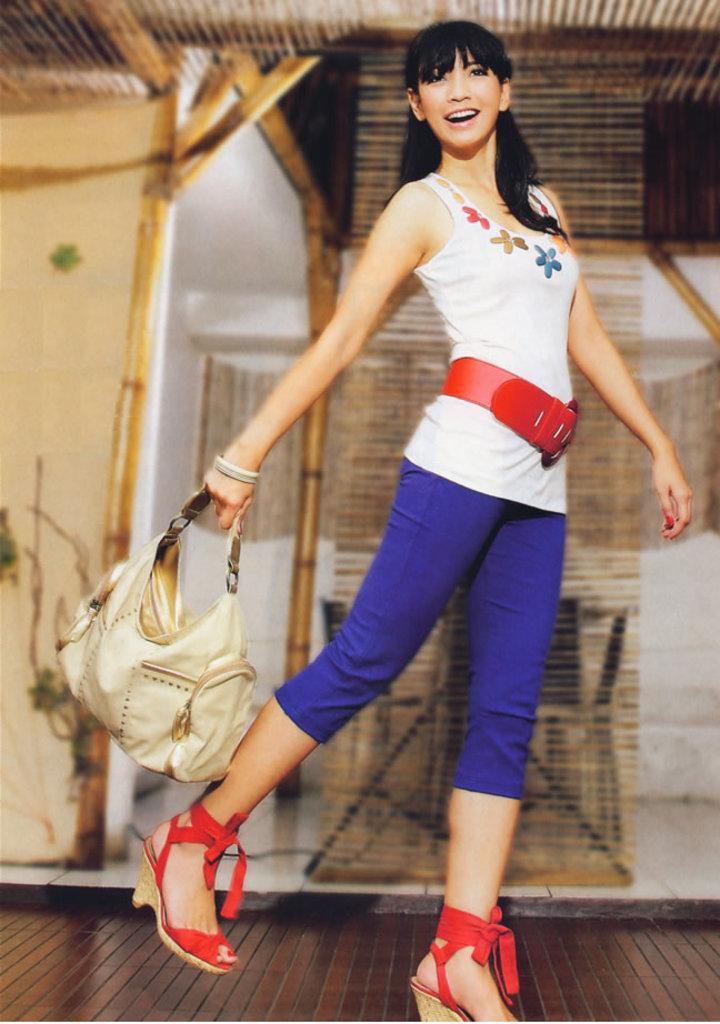In one or two sentences, can you explain what this image depicts? in the picture the woman was walking and catching a bag with her,behind her we can see an architecture. 